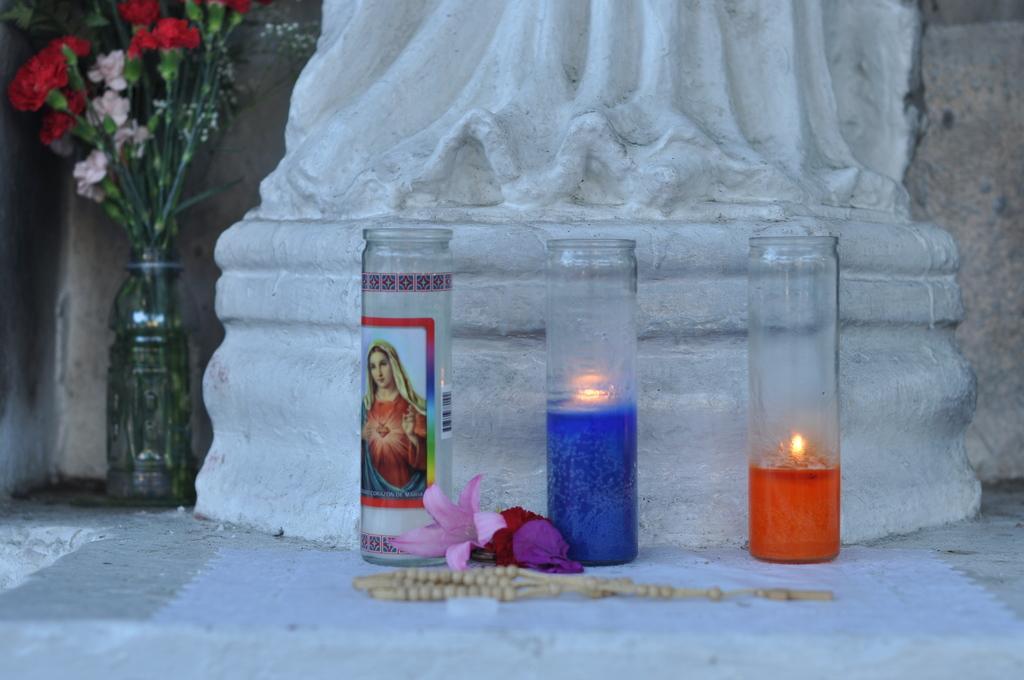Could you give a brief overview of what you see in this image? In this picture consists of stone carving , in front it I can see three bottles , in the bottle I can see a fire , and I can see flowers and there are some flowers kept on it visible on left side , in the middle I can see a chair 